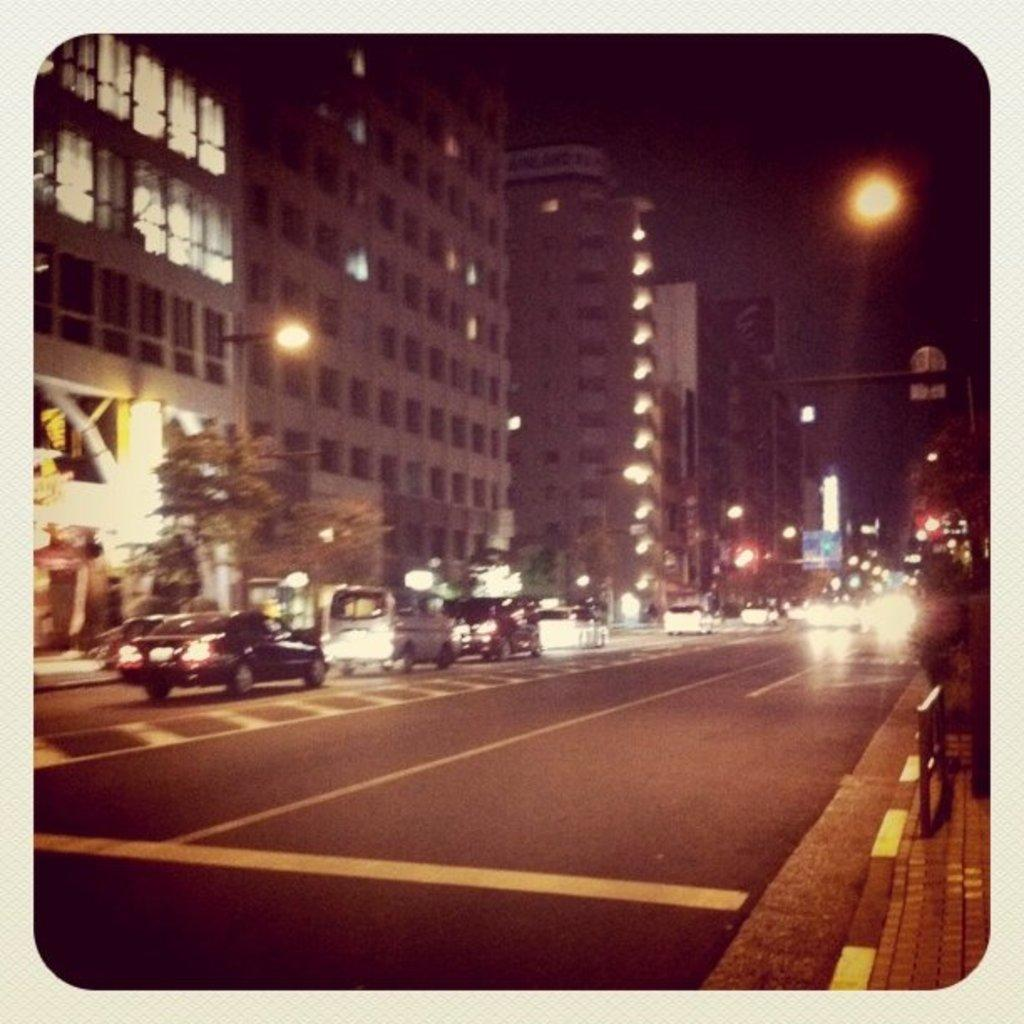What type of structures can be seen in the image? There are buildings in the image. What architectural features are present on the buildings? There are windows visible on the buildings. What type of vegetation is present in the image? There are trees in the image. What type of streetlights are present in the image? There are light-poles in the image. What type of transportation is present in the image? There are vehicles in the image. What type of barrier is present in the image? There is fencing in the image. How would you describe the overall appearance of the image? The image has a dark appearance. What team is playing in the image? There is no team playing in the image; it features buildings, trees, light-poles, vehicles, and fencing. How does the history of the area relate to the image? The image does not provide any information about the history of the area; it only shows the current state of the buildings, trees, light-poles, vehicles, and fencing. 